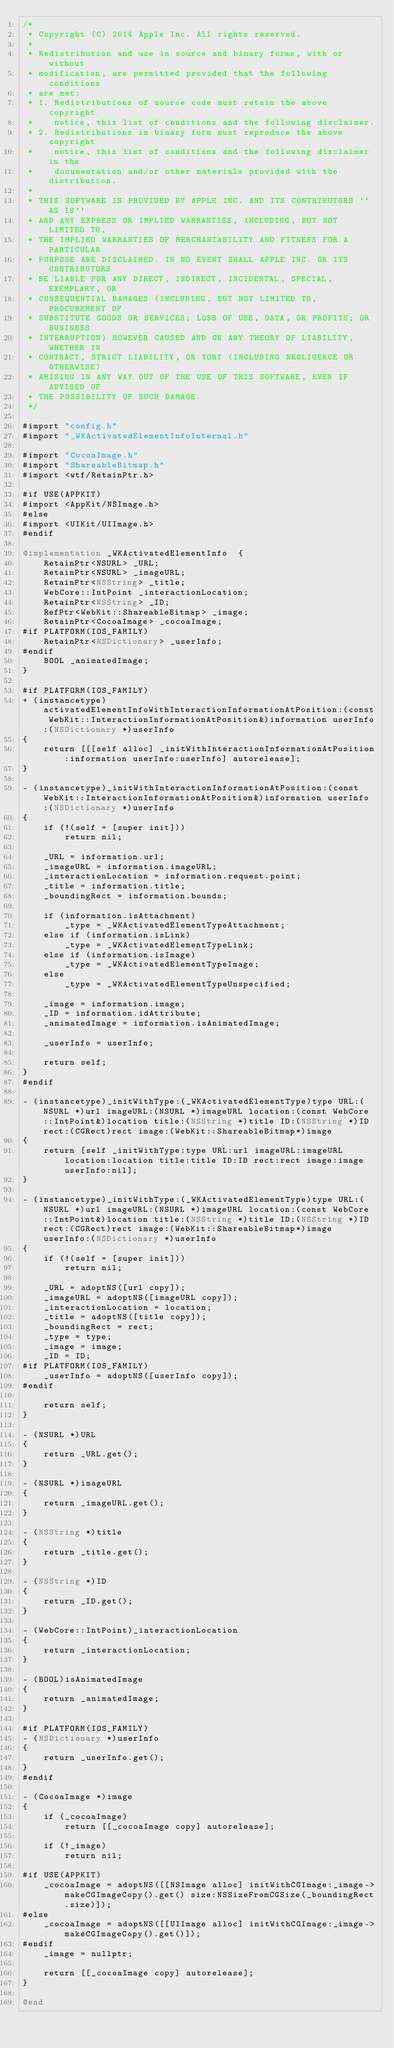<code> <loc_0><loc_0><loc_500><loc_500><_ObjectiveC_>/*
 * Copyright (C) 2014 Apple Inc. All rights reserved.
 *
 * Redistribution and use in source and binary forms, with or without
 * modification, are permitted provided that the following conditions
 * are met:
 * 1. Redistributions of source code must retain the above copyright
 *    notice, this list of conditions and the following disclaimer.
 * 2. Redistributions in binary form must reproduce the above copyright
 *    notice, this list of conditions and the following disclaimer in the
 *    documentation and/or other materials provided with the distribution.
 *
 * THIS SOFTWARE IS PROVIDED BY APPLE INC. AND ITS CONTRIBUTORS ``AS IS''
 * AND ANY EXPRESS OR IMPLIED WARRANTIES, INCLUDING, BUT NOT LIMITED TO,
 * THE IMPLIED WARRANTIES OF MERCHANTABILITY AND FITNESS FOR A PARTICULAR
 * PURPOSE ARE DISCLAIMED. IN NO EVENT SHALL APPLE INC. OR ITS CONTRIBUTORS
 * BE LIABLE FOR ANY DIRECT, INDIRECT, INCIDENTAL, SPECIAL, EXEMPLARY, OR
 * CONSEQUENTIAL DAMAGES (INCLUDING, BUT NOT LIMITED TO, PROCUREMENT OF
 * SUBSTITUTE GOODS OR SERVICES; LOSS OF USE, DATA, OR PROFITS; OR BUSINESS
 * INTERRUPTION) HOWEVER CAUSED AND ON ANY THEORY OF LIABILITY, WHETHER IN
 * CONTRACT, STRICT LIABILITY, OR TORT (INCLUDING NEGLIGENCE OR OTHERWISE)
 * ARISING IN ANY WAY OUT OF THE USE OF THIS SOFTWARE, EVEN IF ADVISED OF
 * THE POSSIBILITY OF SUCH DAMAGE.
 */

#import "config.h"
#import "_WKActivatedElementInfoInternal.h"

#import "CocoaImage.h"
#import "ShareableBitmap.h"
#import <wtf/RetainPtr.h>

#if USE(APPKIT)
#import <AppKit/NSImage.h>
#else
#import <UIKit/UIImage.h>
#endif

@implementation _WKActivatedElementInfo  {
    RetainPtr<NSURL> _URL;
    RetainPtr<NSURL> _imageURL;
    RetainPtr<NSString> _title;
    WebCore::IntPoint _interactionLocation;
    RetainPtr<NSString> _ID;
    RefPtr<WebKit::ShareableBitmap> _image;
    RetainPtr<CocoaImage> _cocoaImage;
#if PLATFORM(IOS_FAMILY)
    RetainPtr<NSDictionary> _userInfo;
#endif
    BOOL _animatedImage;
}

#if PLATFORM(IOS_FAMILY)
+ (instancetype)activatedElementInfoWithInteractionInformationAtPosition:(const WebKit::InteractionInformationAtPosition&)information userInfo:(NSDictionary *)userInfo
{
    return [[[self alloc] _initWithInteractionInformationAtPosition:information userInfo:userInfo] autorelease];
}

- (instancetype)_initWithInteractionInformationAtPosition:(const WebKit::InteractionInformationAtPosition&)information userInfo:(NSDictionary *)userInfo
{
    if (!(self = [super init]))
        return nil;
    
    _URL = information.url;
    _imageURL = information.imageURL;
    _interactionLocation = information.request.point;
    _title = information.title;
    _boundingRect = information.bounds;
    
    if (information.isAttachment)
        _type = _WKActivatedElementTypeAttachment;
    else if (information.isLink)
        _type = _WKActivatedElementTypeLink;
    else if (information.isImage)
        _type = _WKActivatedElementTypeImage;
    else
        _type = _WKActivatedElementTypeUnspecified;
    
    _image = information.image;
    _ID = information.idAttribute;
    _animatedImage = information.isAnimatedImage;

    _userInfo = userInfo;
    
    return self;
}
#endif

- (instancetype)_initWithType:(_WKActivatedElementType)type URL:(NSURL *)url imageURL:(NSURL *)imageURL location:(const WebCore::IntPoint&)location title:(NSString *)title ID:(NSString *)ID rect:(CGRect)rect image:(WebKit::ShareableBitmap*)image
{
    return [self _initWithType:type URL:url imageURL:imageURL location:location title:title ID:ID rect:rect image:image userInfo:nil];
}

- (instancetype)_initWithType:(_WKActivatedElementType)type URL:(NSURL *)url imageURL:(NSURL *)imageURL location:(const WebCore::IntPoint&)location title:(NSString *)title ID:(NSString *)ID rect:(CGRect)rect image:(WebKit::ShareableBitmap*)image userInfo:(NSDictionary *)userInfo
{
    if (!(self = [super init]))
        return nil;

    _URL = adoptNS([url copy]);
    _imageURL = adoptNS([imageURL copy]);
    _interactionLocation = location;
    _title = adoptNS([title copy]);
    _boundingRect = rect;
    _type = type;
    _image = image;
    _ID = ID;
#if PLATFORM(IOS_FAMILY)
    _userInfo = adoptNS([userInfo copy]);
#endif

    return self;
}

- (NSURL *)URL
{
    return _URL.get();
}

- (NSURL *)imageURL
{
    return _imageURL.get();
}

- (NSString *)title
{
    return _title.get();
}

- (NSString *)ID
{
    return _ID.get();
}

- (WebCore::IntPoint)_interactionLocation
{
    return _interactionLocation;
}

- (BOOL)isAnimatedImage
{
    return _animatedImage;
}

#if PLATFORM(IOS_FAMILY)
- (NSDictionary *)userInfo
{
    return _userInfo.get();
}
#endif

- (CocoaImage *)image
{
    if (_cocoaImage)
        return [[_cocoaImage copy] autorelease];

    if (!_image)
        return nil;

#if USE(APPKIT)
    _cocoaImage = adoptNS([[NSImage alloc] initWithCGImage:_image->makeCGImageCopy().get() size:NSSizeFromCGSize(_boundingRect.size)]);
#else
    _cocoaImage = adoptNS([[UIImage alloc] initWithCGImage:_image->makeCGImageCopy().get()]);
#endif
    _image = nullptr;

    return [[_cocoaImage copy] autorelease];
}

@end
</code> 